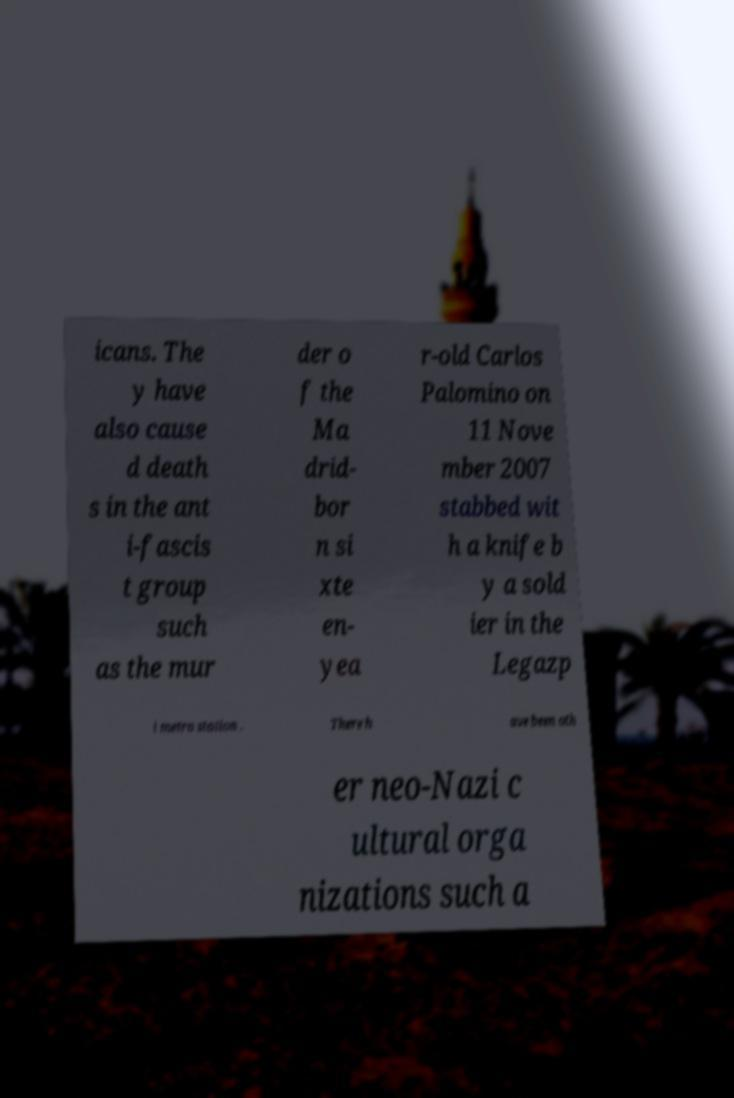Please read and relay the text visible in this image. What does it say? icans. The y have also cause d death s in the ant i-fascis t group such as the mur der o f the Ma drid- bor n si xte en- yea r-old Carlos Palomino on 11 Nove mber 2007 stabbed wit h a knife b y a sold ier in the Legazp i metro station . There h ave been oth er neo-Nazi c ultural orga nizations such a 